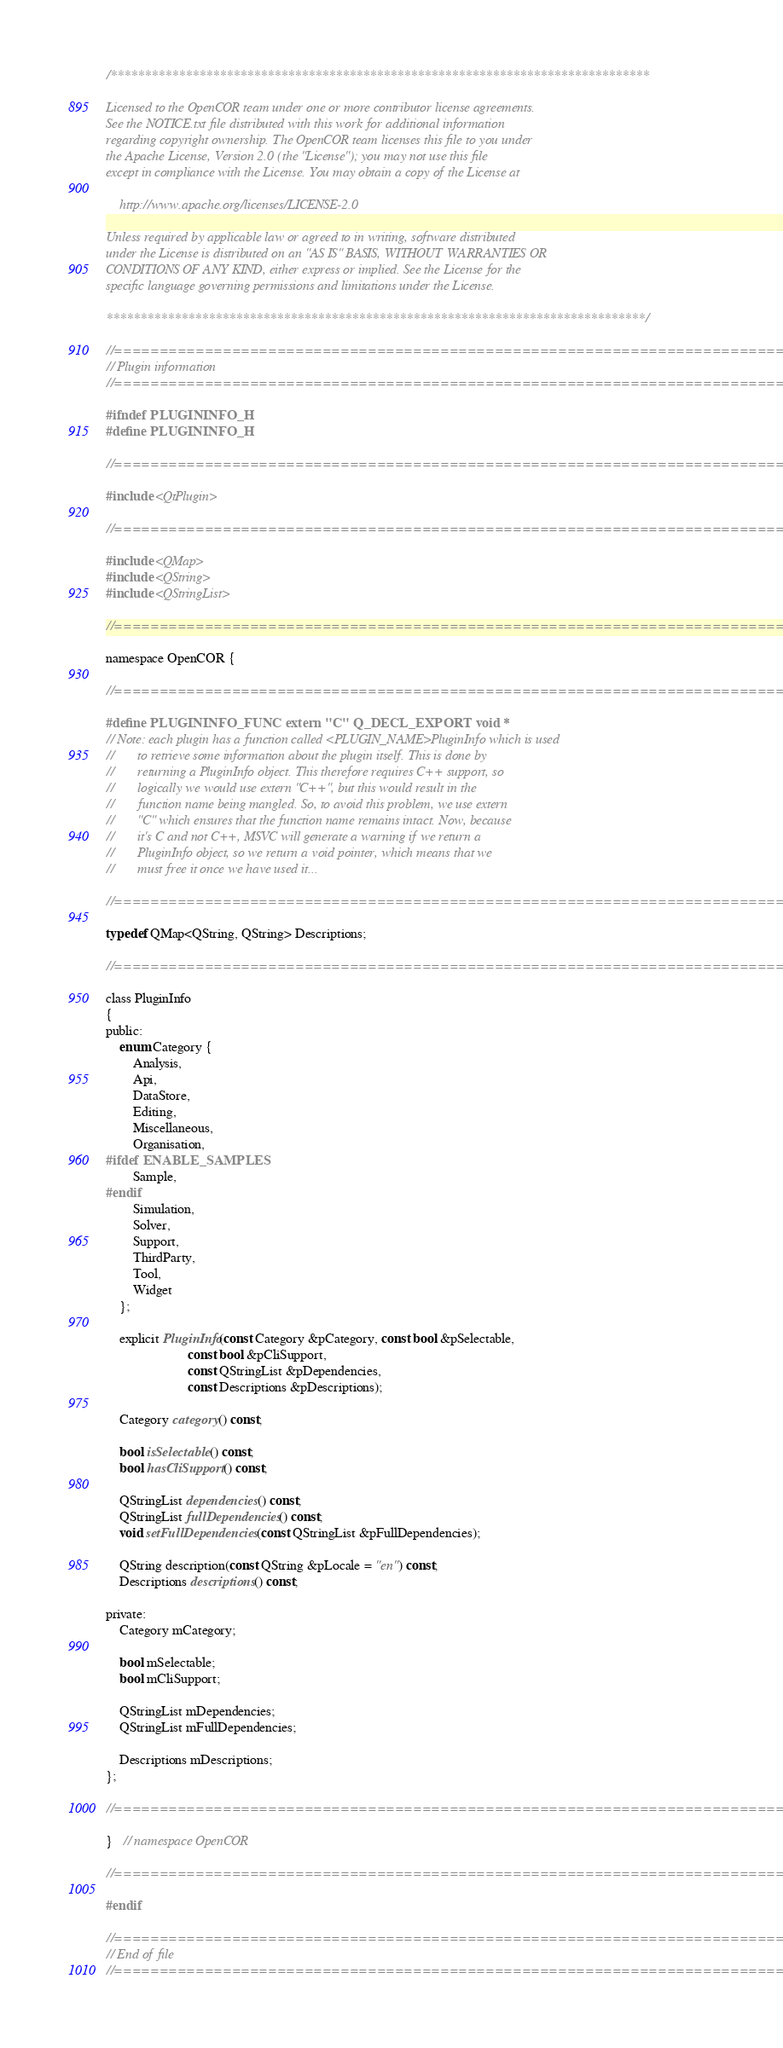<code> <loc_0><loc_0><loc_500><loc_500><_C_>/*******************************************************************************

Licensed to the OpenCOR team under one or more contributor license agreements.
See the NOTICE.txt file distributed with this work for additional information
regarding copyright ownership. The OpenCOR team licenses this file to you under
the Apache License, Version 2.0 (the "License"); you may not use this file
except in compliance with the License. You may obtain a copy of the License at

    http://www.apache.org/licenses/LICENSE-2.0

Unless required by applicable law or agreed to in writing, software distributed
under the License is distributed on an "AS IS" BASIS, WITHOUT WARRANTIES OR
CONDITIONS OF ANY KIND, either express or implied. See the License for the
specific language governing permissions and limitations under the License.

*******************************************************************************/

//==============================================================================
// Plugin information
//==============================================================================

#ifndef PLUGININFO_H
#define PLUGININFO_H

//==============================================================================

#include <QtPlugin>

//==============================================================================

#include <QMap>
#include <QString>
#include <QStringList>

//==============================================================================

namespace OpenCOR {

//==============================================================================

#define PLUGININFO_FUNC extern "C" Q_DECL_EXPORT void *
// Note: each plugin has a function called <PLUGIN_NAME>PluginInfo which is used
//       to retrieve some information about the plugin itself. This is done by
//       returning a PluginInfo object. This therefore requires C++ support, so
//       logically we would use extern "C++", but this would result in the
//       function name being mangled. So, to avoid this problem, we use extern
//       "C" which ensures that the function name remains intact. Now, because
//       it's C and not C++, MSVC will generate a warning if we return a
//       PluginInfo object, so we return a void pointer, which means that we
//       must free it once we have used it...

//==============================================================================

typedef QMap<QString, QString> Descriptions;

//==============================================================================

class PluginInfo
{
public:
    enum Category {
        Analysis,
        Api,
        DataStore,
        Editing,
        Miscellaneous,
        Organisation,
#ifdef ENABLE_SAMPLES
        Sample,
#endif
        Simulation,
        Solver,
        Support,
        ThirdParty,
        Tool,
        Widget
    };

    explicit PluginInfo(const Category &pCategory, const bool &pSelectable,
                        const bool &pCliSupport,
                        const QStringList &pDependencies,
                        const Descriptions &pDescriptions);

    Category category() const;

    bool isSelectable() const;
    bool hasCliSupport() const;

    QStringList dependencies() const;
    QStringList fullDependencies() const;
    void setFullDependencies(const QStringList &pFullDependencies);

    QString description(const QString &pLocale = "en") const;
    Descriptions descriptions() const;

private:
    Category mCategory;

    bool mSelectable;
    bool mCliSupport;

    QStringList mDependencies;
    QStringList mFullDependencies;

    Descriptions mDescriptions;
};

//==============================================================================

}   // namespace OpenCOR

//==============================================================================

#endif

//==============================================================================
// End of file
//==============================================================================
</code> 